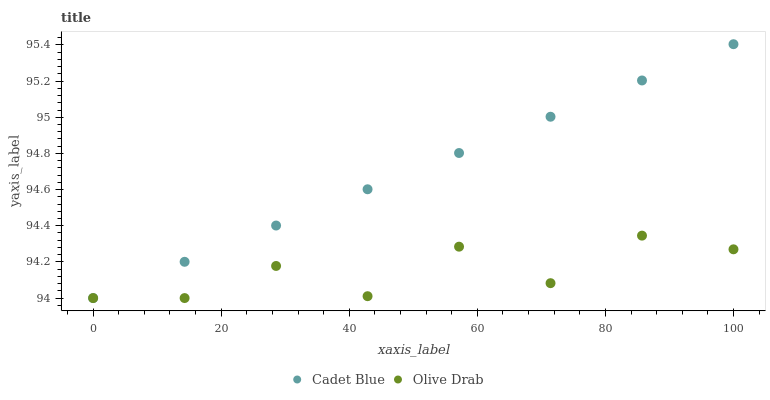Does Olive Drab have the minimum area under the curve?
Answer yes or no. Yes. Does Cadet Blue have the maximum area under the curve?
Answer yes or no. Yes. Does Olive Drab have the maximum area under the curve?
Answer yes or no. No. Is Cadet Blue the smoothest?
Answer yes or no. Yes. Is Olive Drab the roughest?
Answer yes or no. Yes. Is Olive Drab the smoothest?
Answer yes or no. No. Does Cadet Blue have the lowest value?
Answer yes or no. Yes. Does Cadet Blue have the highest value?
Answer yes or no. Yes. Does Olive Drab have the highest value?
Answer yes or no. No. Does Cadet Blue intersect Olive Drab?
Answer yes or no. Yes. Is Cadet Blue less than Olive Drab?
Answer yes or no. No. Is Cadet Blue greater than Olive Drab?
Answer yes or no. No. 